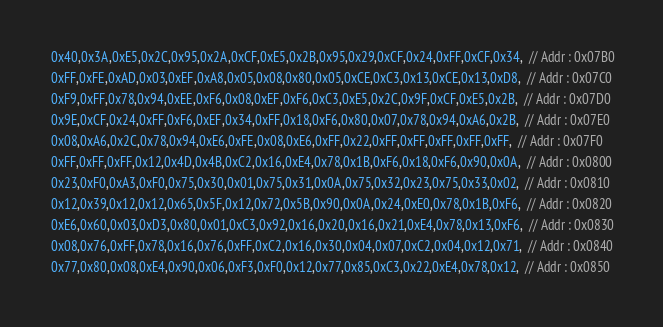Convert code to text. <code><loc_0><loc_0><loc_500><loc_500><_C_> 0x40,0x3A,0xE5,0x2C,0x95,0x2A,0xCF,0xE5,0x2B,0x95,0x29,0xCF,0x24,0xFF,0xCF,0x34,  // Addr : 0x07B0
 0xFF,0xFE,0xAD,0x03,0xEF,0xA8,0x05,0x08,0x80,0x05,0xCE,0xC3,0x13,0xCE,0x13,0xD8,  // Addr : 0x07C0
 0xF9,0xFF,0x78,0x94,0xEE,0xF6,0x08,0xEF,0xF6,0xC3,0xE5,0x2C,0x9F,0xCF,0xE5,0x2B,  // Addr : 0x07D0
 0x9E,0xCF,0x24,0xFF,0xF6,0xEF,0x34,0xFF,0x18,0xF6,0x80,0x07,0x78,0x94,0xA6,0x2B,  // Addr : 0x07E0
 0x08,0xA6,0x2C,0x78,0x94,0xE6,0xFE,0x08,0xE6,0xFF,0x22,0xFF,0xFF,0xFF,0xFF,0xFF,  // Addr : 0x07F0
 0xFF,0xFF,0xFF,0x12,0x4D,0x4B,0xC2,0x16,0xE4,0x78,0x1B,0xF6,0x18,0xF6,0x90,0x0A,  // Addr : 0x0800
 0x23,0xF0,0xA3,0xF0,0x75,0x30,0x01,0x75,0x31,0x0A,0x75,0x32,0x23,0x75,0x33,0x02,  // Addr : 0x0810
 0x12,0x39,0x12,0x12,0x65,0x5F,0x12,0x72,0x5B,0x90,0x0A,0x24,0xE0,0x78,0x1B,0xF6,  // Addr : 0x0820
 0xE6,0x60,0x03,0xD3,0x80,0x01,0xC3,0x92,0x16,0x20,0x16,0x21,0xE4,0x78,0x13,0xF6,  // Addr : 0x0830
 0x08,0x76,0xFF,0x78,0x16,0x76,0xFF,0xC2,0x16,0x30,0x04,0x07,0xC2,0x04,0x12,0x71,  // Addr : 0x0840
 0x77,0x80,0x08,0xE4,0x90,0x06,0xF3,0xF0,0x12,0x77,0x85,0xC3,0x22,0xE4,0x78,0x12,  // Addr : 0x0850</code> 